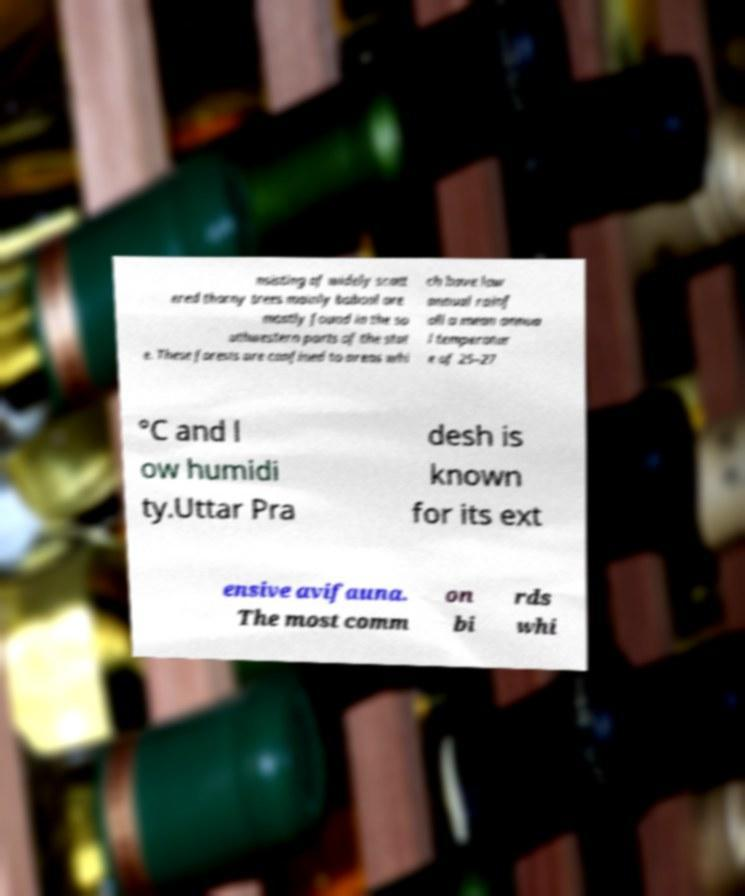Can you read and provide the text displayed in the image?This photo seems to have some interesting text. Can you extract and type it out for me? nsisting of widely scatt ered thorny trees mainly babool are mostly found in the so uthwestern parts of the stat e. These forests are confined to areas whi ch have low annual rainf all a mean annua l temperatur e of 25–27 °C and l ow humidi ty.Uttar Pra desh is known for its ext ensive avifauna. The most comm on bi rds whi 